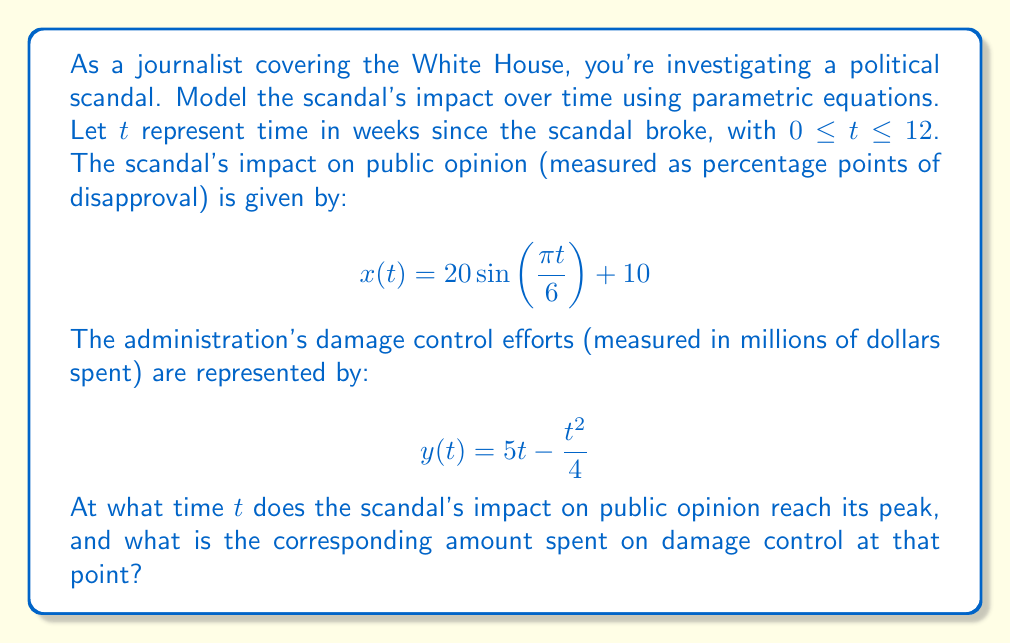What is the answer to this math problem? To solve this problem, we need to follow these steps:

1) First, we need to find when the scandal's impact on public opinion reaches its peak. This corresponds to finding the maximum value of $x(t)$.

2) The function $x(t) = 20\sin(\frac{\pi t}{6}) + 10$ is a sine function with amplitude 20, period 12, and shifted up by 10 units.

3) We know that a sine function reaches its maximum value when its argument is $\frac{\pi}{2}$ (or 90 degrees). So we need to solve:

   $$\frac{\pi t}{6} = \frac{\pi}{2}$$

4) Solving this equation:
   
   $$t = 3$$

5) So the scandal's impact peaks at $t = 3$ weeks.

6) Now we need to find the amount spent on damage control at this time. We do this by evaluating $y(t)$ at $t = 3$:

   $$y(3) = 5(3) - \frac{3^2}{4} = 15 - \frac{9}{4} = 15 - 2.25 = 12.75$$

Therefore, when the scandal's impact peaks at 3 weeks, the administration has spent $12.75 million on damage control.
Answer: The scandal's impact on public opinion peaks at $t = 3$ weeks, at which point the administration has spent $12.75$ million on damage control. 